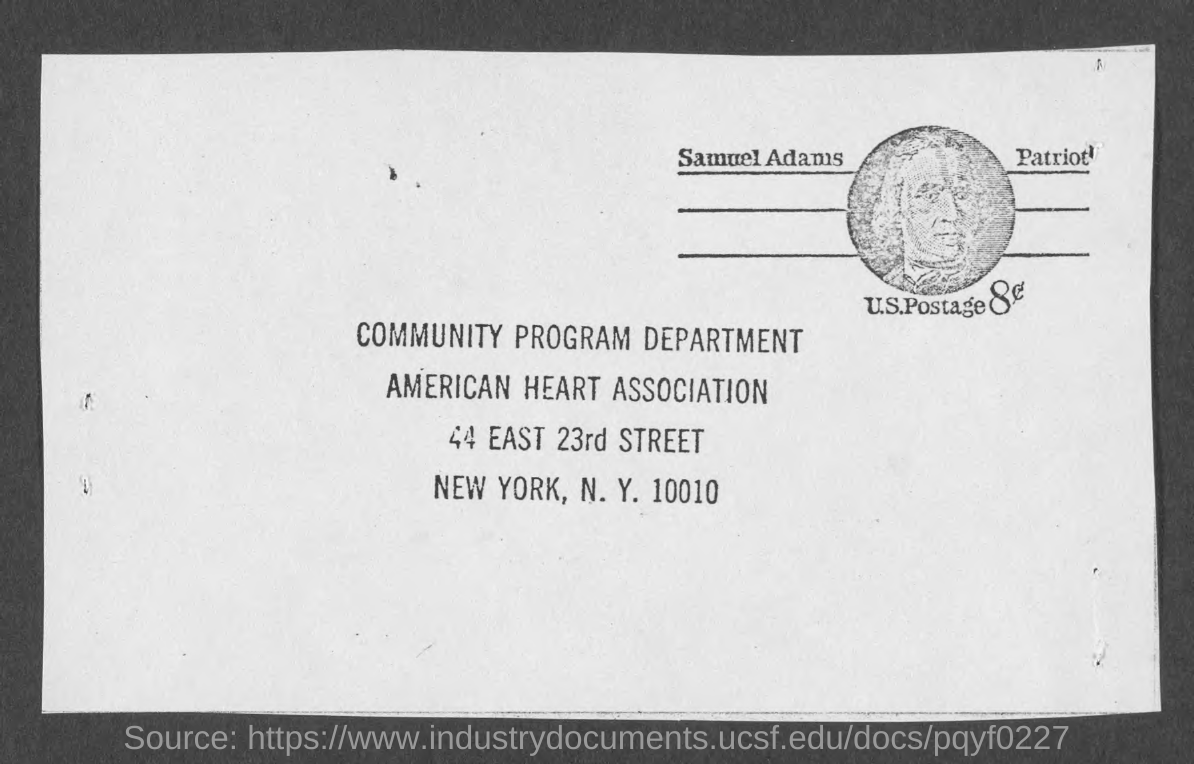Which department is mentioned?
Your answer should be compact. Community Program Department. Which association is mentioned?
Offer a terse response. AMERICAN HEART ASSOCIATION. Which city is mentioned?
Ensure brevity in your answer.  N. Y. What is the zip code mentioned?
Keep it short and to the point. 10010. 